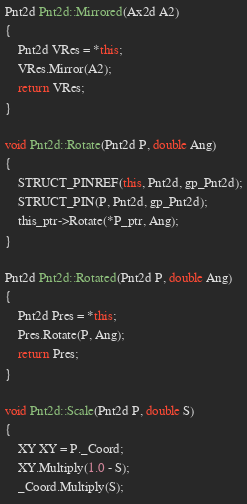Convert code to text. <code><loc_0><loc_0><loc_500><loc_500><_C++_>
Pnt2d Pnt2d::Mirrored(Ax2d A2)
{
	Pnt2d VRes = *this;
	VRes.Mirror(A2);
	return VRes;
}

void Pnt2d::Rotate(Pnt2d P, double Ang)
{
	STRUCT_PINREF(this, Pnt2d, gp_Pnt2d);
	STRUCT_PIN(P, Pnt2d, gp_Pnt2d);
	this_ptr->Rotate(*P_ptr, Ang);
}

Pnt2d Pnt2d::Rotated(Pnt2d P, double Ang)
{
	Pnt2d Pres = *this;
	Pres.Rotate(P, Ang);
	return Pres;
}

void Pnt2d::Scale(Pnt2d P, double S)
{
	XY XY = P._Coord;
	XY.Multiply(1.0 - S);
	_Coord.Multiply(S);</code> 